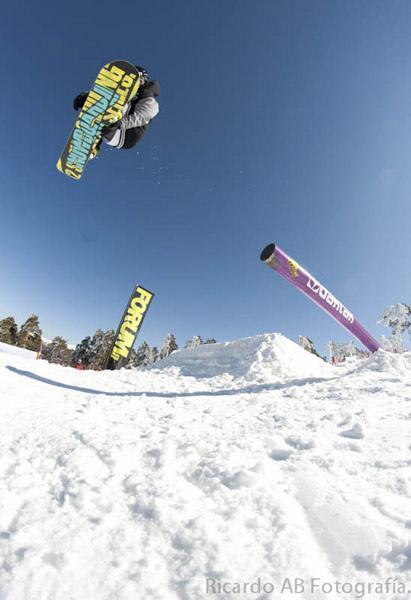How many people are in the photo?
Give a very brief answer. 1. How many orange cones can be seen?
Give a very brief answer. 0. 